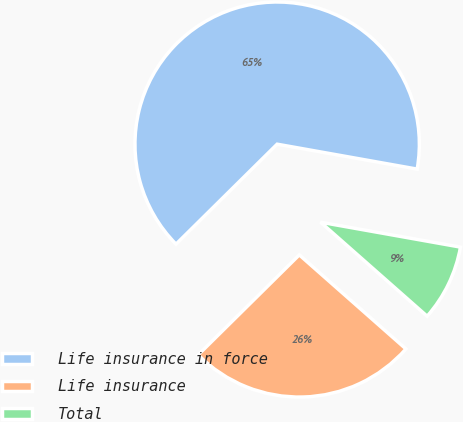Convert chart to OTSL. <chart><loc_0><loc_0><loc_500><loc_500><pie_chart><fcel>Life insurance in force<fcel>Life insurance<fcel>Total<nl><fcel>65.22%<fcel>26.09%<fcel>8.7%<nl></chart> 